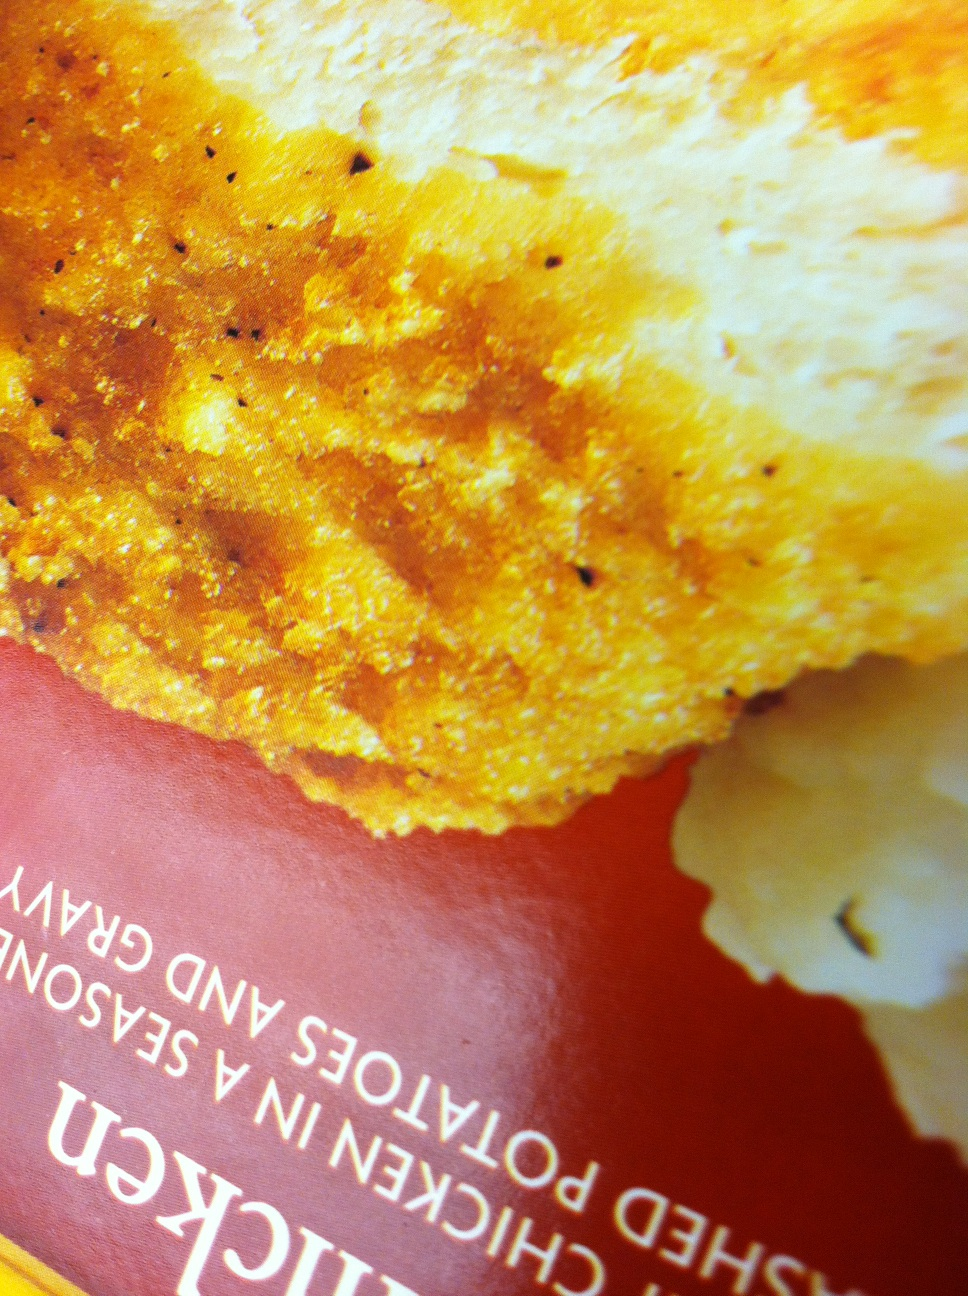Can you describe the texture of the chicken shown in the image? The chicken has a crispy, golden-brown exterior that suggests it's been either fried or baked to achieve a crunchy texture, while possibly retaining juiciness inside. 